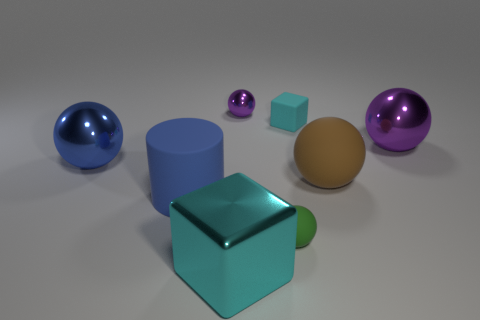Are there any other big objects of the same shape as the green object?
Offer a very short reply. Yes. What number of green rubber spheres are there?
Offer a very short reply. 1. How many large objects are cylinders or blue spheres?
Your response must be concise. 2. What is the color of the rubber object that is to the left of the block to the left of the small ball that is behind the small green rubber object?
Your answer should be very brief. Blue. What number of other things are there of the same color as the rubber block?
Ensure brevity in your answer.  1. How many metallic things are big blue things or large cyan cylinders?
Keep it short and to the point. 1. Does the block to the right of the tiny shiny sphere have the same color as the tiny rubber thing that is in front of the tiny cyan rubber thing?
Your answer should be very brief. No. Are there any other things that have the same material as the green ball?
Give a very brief answer. Yes. There is another rubber object that is the same shape as the green object; what size is it?
Provide a short and direct response. Large. Is the number of big metal spheres on the right side of the large blue matte cylinder greater than the number of rubber cylinders?
Your response must be concise. No. 